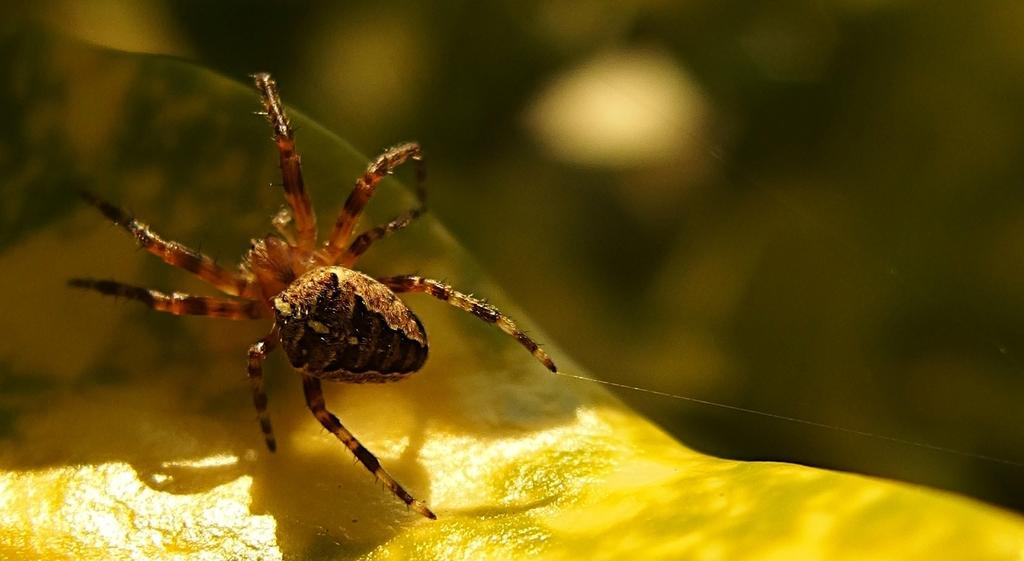What type of creature is in the image? There is an insect in the image. What colors can be seen on the insect? The insect has brown and black colors. Where is the insect located in the image? The insect is on an object. How would you describe the background of the image? The background of the image is blurred. What type of army is depicted in the image? There is no army present in the image; it features an insect on an object with a blurred background. What kind of patch can be seen on the insect in the image? There is no patch present on the insect in the image; it has brown and black colors. 